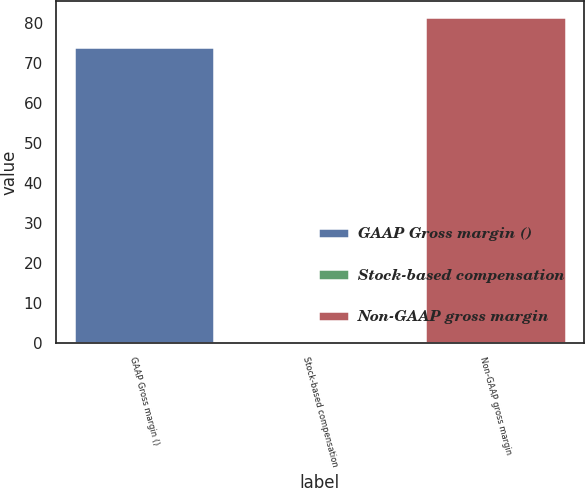Convert chart. <chart><loc_0><loc_0><loc_500><loc_500><bar_chart><fcel>GAAP Gross margin ()<fcel>Stock-based compensation<fcel>Non-GAAP gross margin<nl><fcel>74.1<fcel>0.3<fcel>81.51<nl></chart> 